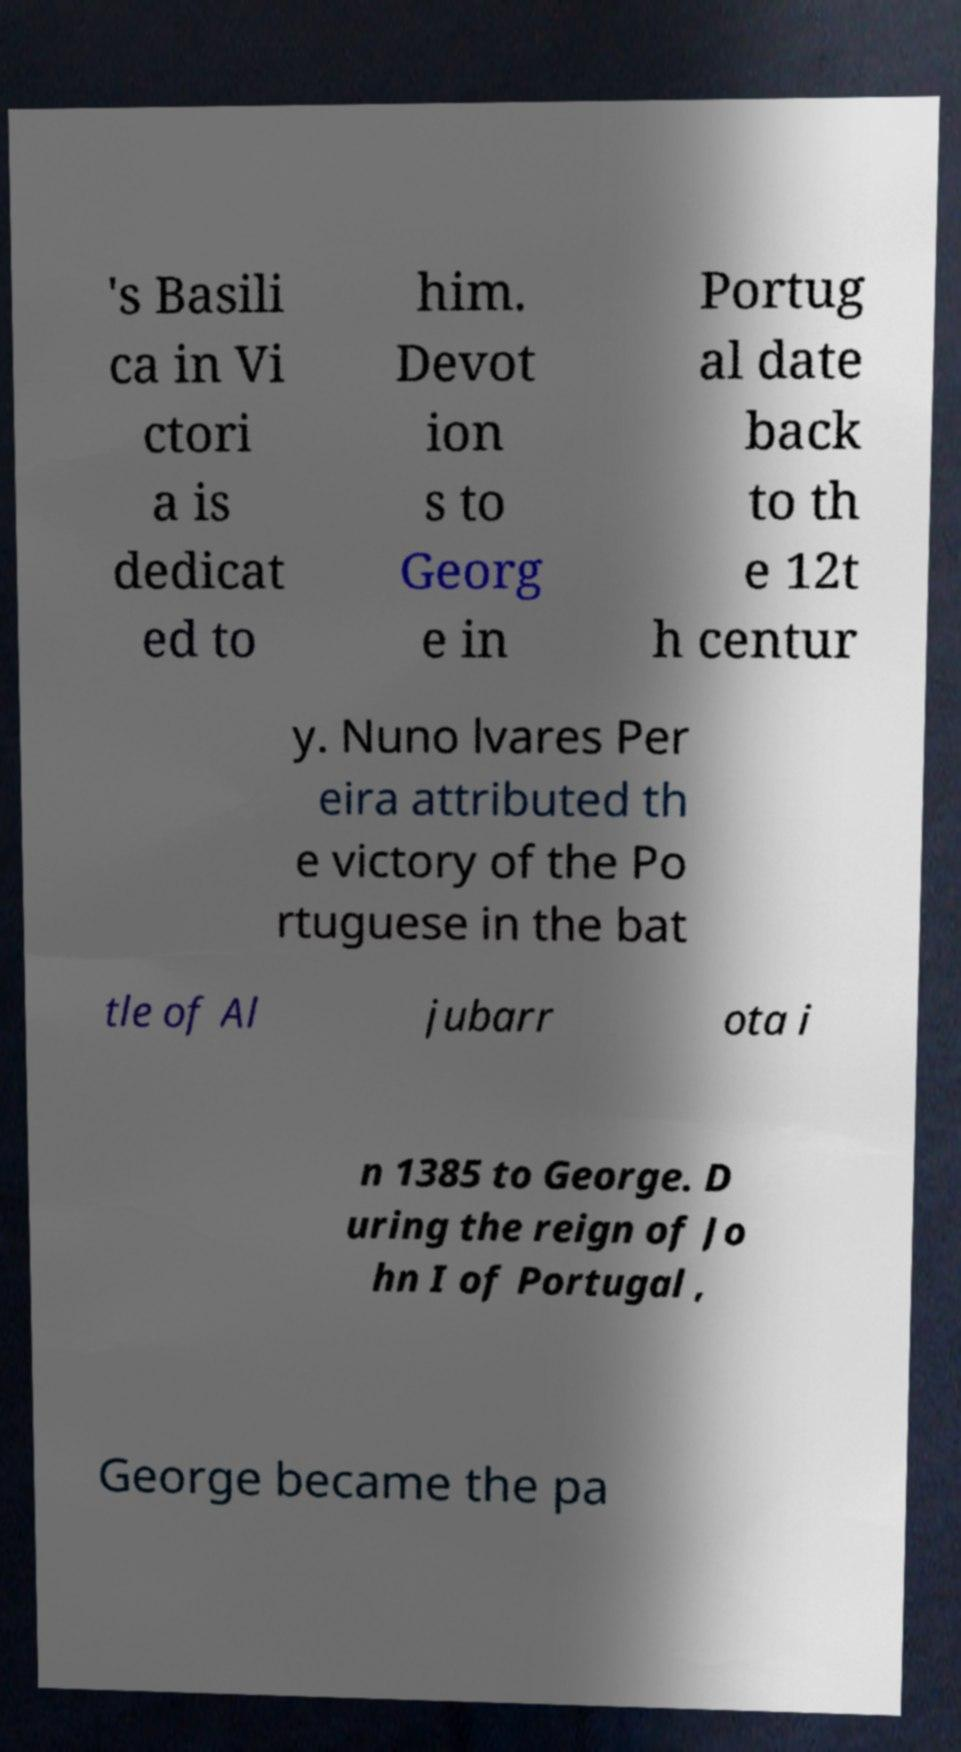Could you extract and type out the text from this image? 's Basili ca in Vi ctori a is dedicat ed to him. Devot ion s to Georg e in Portug al date back to th e 12t h centur y. Nuno lvares Per eira attributed th e victory of the Po rtuguese in the bat tle of Al jubarr ota i n 1385 to George. D uring the reign of Jo hn I of Portugal , George became the pa 